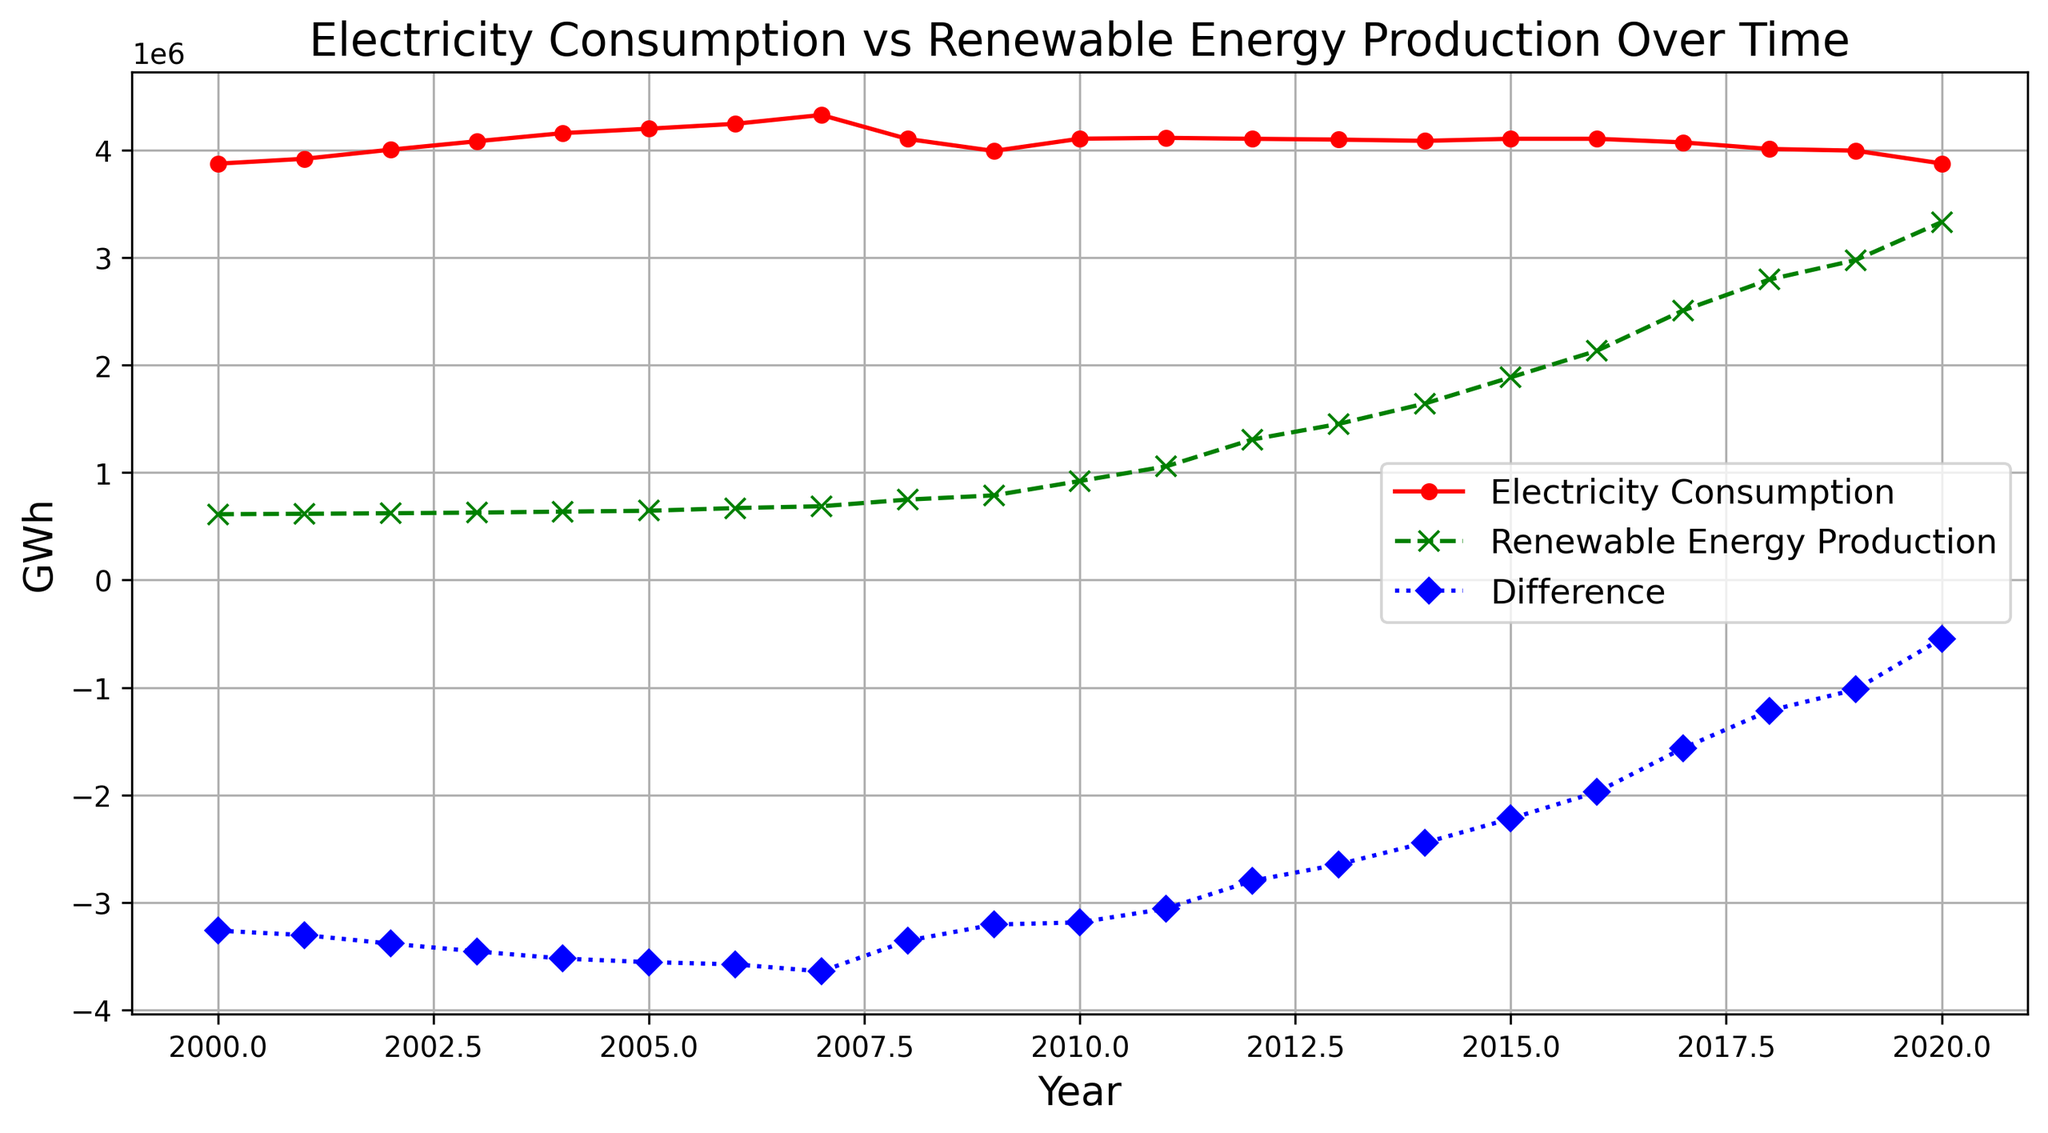What was the trend in electricity consumption from 2000 to 2020? By looking at the red line which denotes electricity consumption, you can see a general slight increase from 2000 to 2007, followed by fluctuations and a noticeable dip around 2008, and then a relatively stable period from 2009 to 2020.
Answer: Increasing until 2007, then fluctuating with slight decrease How did the production of renewable energy change from 2000 to 2020? The green line represents renewable energy production. It shows a steady increase over the entire period from 2000 to 2020. This can be seen as the green line continuously moves upward.
Answer: Steadily increasing In which year did the difference between electricity consumption and renewable energy production first drop below 2,000,000 GWh? By inspecting the blue line that represents the difference, it first drops below the -2,000,000 GWh mark between 2016 and 2017. In 2017, the difference is around -1,563,501 GWh.
Answer: 2017 Between which two consecutive years did renewable energy production see the highest increase? To find this, identify the steepest upward slope in the green line. The steepest increase occurs between 2019 and 2020.
Answer: 2019 and 2020 In which year was the electricity consumption the lowest according to the figure? Look at the red line for the lowest point. The lowest electricity consumption is in 2020.
Answer: 2020 What is the trend of the difference between electricity consumption and renewable energy production over the years? Viewing the blue line, you see that the difference decreases over time, becoming less negative. This indicates that the gap between electricity consumption and renewable energy production is closing.
Answer: Decreasing trend In which year was the renewable energy production approximately double compared to the year 2000? In 2000, renewable energy production was 613,000 GWh. Looking for the year where production is roughly double this value (around 1,226,000 GWh), 2012 or 2013 fits this as production in 2012 is 1,308,000 GWh and in 2013 is 1,453,000 GWh.
Answer: 2012 Was there any year when the renewable energy production surpassed 3,000,000 GWh? Look for where the green line crosses the 3,000,000 GWh mark. Renewables surpassed this in 2020, reaching 3,331,500 GWh.
Answer: 2020 How does electricity consumption compare between the highest point and the lowest point in the given period? The highest electricity consumption was around 4,327,630 GWh in 2007, and the lowest was around 3,876,445 GWh in 2020. The comparison shows that the highest consumption is significantly higher.
Answer: Highest was much higher In which year did the renewable energy production surpass 2,000,000 GWh for the first time? Look at the green line to find when it first exceeds 2,000,000 GWh, which happens in 2016.
Answer: 2016 